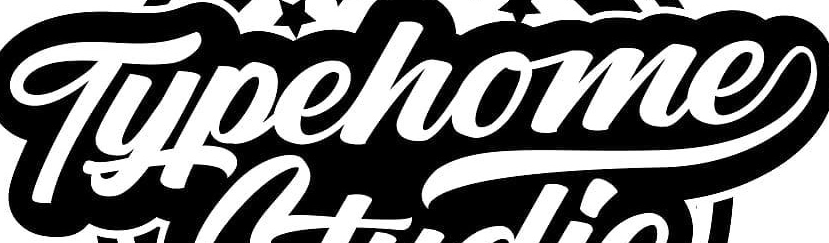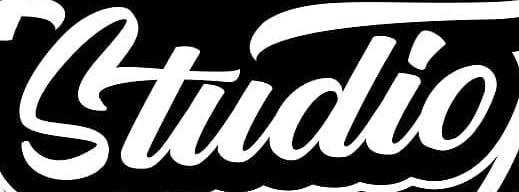Read the text from these images in sequence, separated by a semicolon. Typehome; Studio 